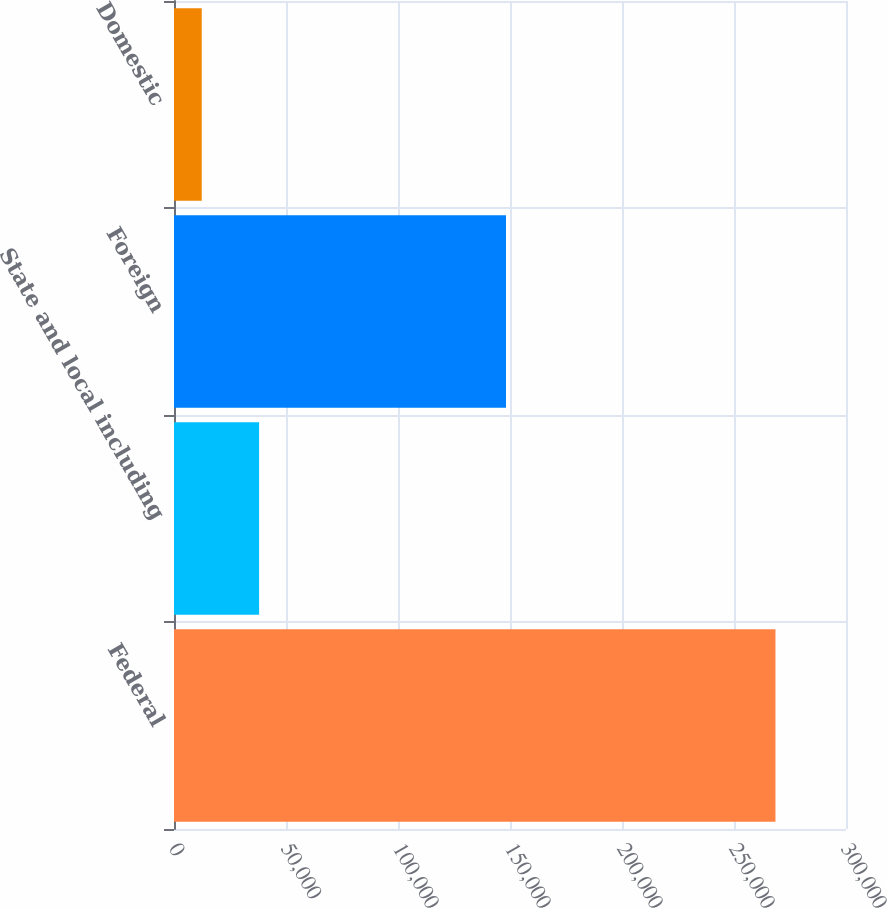Convert chart to OTSL. <chart><loc_0><loc_0><loc_500><loc_500><bar_chart><fcel>Federal<fcel>State and local including<fcel>Foreign<fcel>Domestic<nl><fcel>268508<fcel>37996.4<fcel>148208<fcel>12384<nl></chart> 